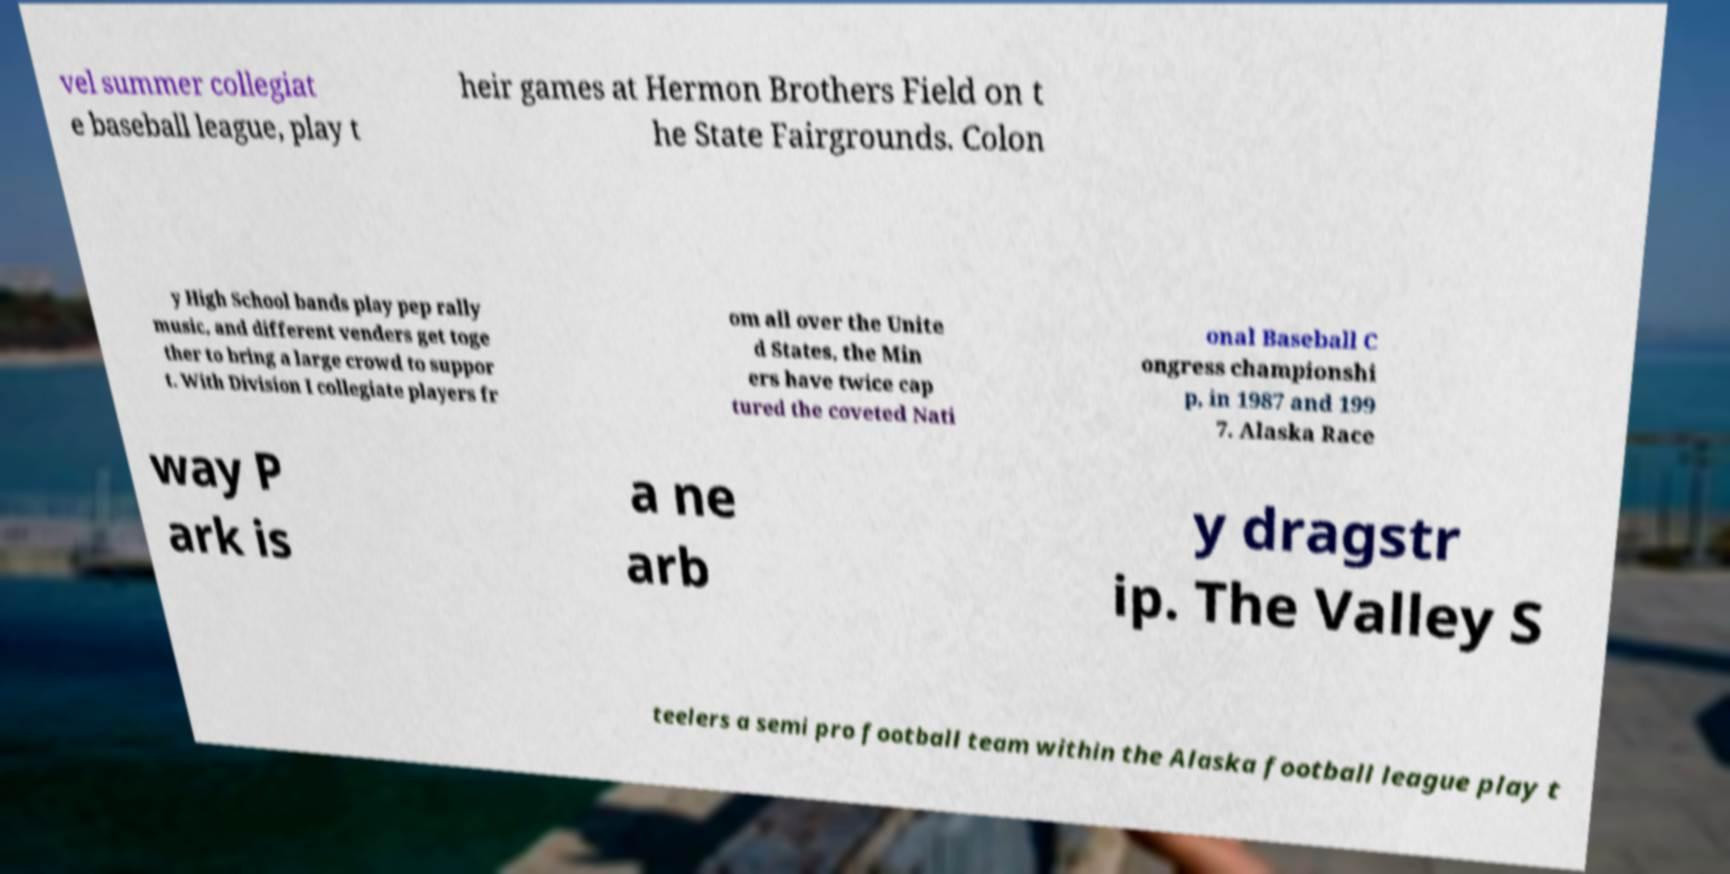I need the written content from this picture converted into text. Can you do that? vel summer collegiat e baseball league, play t heir games at Hermon Brothers Field on t he State Fairgrounds. Colon y High School bands play pep rally music, and different venders get toge ther to bring a large crowd to suppor t. With Division I collegiate players fr om all over the Unite d States, the Min ers have twice cap tured the coveted Nati onal Baseball C ongress championshi p, in 1987 and 199 7. Alaska Race way P ark is a ne arb y dragstr ip. The Valley S teelers a semi pro football team within the Alaska football league play t 